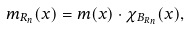<formula> <loc_0><loc_0><loc_500><loc_500>m _ { R _ { n } } ( x ) & = m ( x ) \cdot \chi _ { B _ { R _ { n } } } ( x ) ,</formula> 